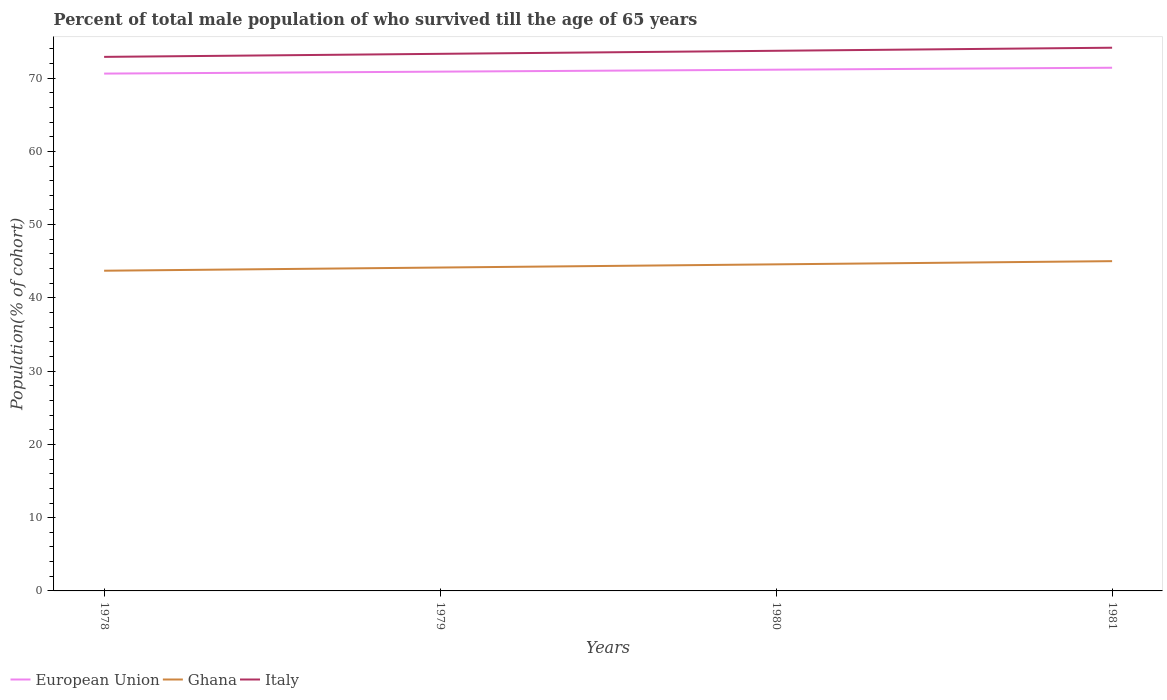How many different coloured lines are there?
Offer a terse response. 3. Is the number of lines equal to the number of legend labels?
Provide a short and direct response. Yes. Across all years, what is the maximum percentage of total male population who survived till the age of 65 years in Italy?
Offer a very short reply. 72.9. In which year was the percentage of total male population who survived till the age of 65 years in Italy maximum?
Offer a terse response. 1978. What is the total percentage of total male population who survived till the age of 65 years in Ghana in the graph?
Give a very brief answer. -1.3. What is the difference between the highest and the second highest percentage of total male population who survived till the age of 65 years in Italy?
Keep it short and to the point. 1.25. Is the percentage of total male population who survived till the age of 65 years in Ghana strictly greater than the percentage of total male population who survived till the age of 65 years in Italy over the years?
Provide a succinct answer. Yes. How many lines are there?
Provide a succinct answer. 3. Does the graph contain any zero values?
Offer a terse response. No. What is the title of the graph?
Your response must be concise. Percent of total male population of who survived till the age of 65 years. Does "High income: OECD" appear as one of the legend labels in the graph?
Offer a terse response. No. What is the label or title of the X-axis?
Make the answer very short. Years. What is the label or title of the Y-axis?
Give a very brief answer. Population(% of cohort). What is the Population(% of cohort) in European Union in 1978?
Your response must be concise. 70.62. What is the Population(% of cohort) of Ghana in 1978?
Keep it short and to the point. 43.71. What is the Population(% of cohort) in Italy in 1978?
Your answer should be very brief. 72.9. What is the Population(% of cohort) of European Union in 1979?
Give a very brief answer. 70.89. What is the Population(% of cohort) in Ghana in 1979?
Ensure brevity in your answer.  44.15. What is the Population(% of cohort) in Italy in 1979?
Your answer should be very brief. 73.32. What is the Population(% of cohort) of European Union in 1980?
Your answer should be very brief. 71.15. What is the Population(% of cohort) of Ghana in 1980?
Make the answer very short. 44.58. What is the Population(% of cohort) of Italy in 1980?
Your answer should be compact. 73.74. What is the Population(% of cohort) in European Union in 1981?
Ensure brevity in your answer.  71.42. What is the Population(% of cohort) in Ghana in 1981?
Provide a succinct answer. 45.02. What is the Population(% of cohort) of Italy in 1981?
Offer a terse response. 74.15. Across all years, what is the maximum Population(% of cohort) in European Union?
Offer a terse response. 71.42. Across all years, what is the maximum Population(% of cohort) of Ghana?
Ensure brevity in your answer.  45.02. Across all years, what is the maximum Population(% of cohort) of Italy?
Your answer should be compact. 74.15. Across all years, what is the minimum Population(% of cohort) in European Union?
Give a very brief answer. 70.62. Across all years, what is the minimum Population(% of cohort) of Ghana?
Provide a succinct answer. 43.71. Across all years, what is the minimum Population(% of cohort) in Italy?
Your answer should be very brief. 72.9. What is the total Population(% of cohort) of European Union in the graph?
Make the answer very short. 284.09. What is the total Population(% of cohort) in Ghana in the graph?
Your answer should be very brief. 177.45. What is the total Population(% of cohort) in Italy in the graph?
Provide a short and direct response. 294.11. What is the difference between the Population(% of cohort) in European Union in 1978 and that in 1979?
Provide a succinct answer. -0.27. What is the difference between the Population(% of cohort) of Ghana in 1978 and that in 1979?
Your response must be concise. -0.43. What is the difference between the Population(% of cohort) in Italy in 1978 and that in 1979?
Provide a short and direct response. -0.42. What is the difference between the Population(% of cohort) in European Union in 1978 and that in 1980?
Give a very brief answer. -0.53. What is the difference between the Population(% of cohort) of Ghana in 1978 and that in 1980?
Give a very brief answer. -0.87. What is the difference between the Population(% of cohort) in Italy in 1978 and that in 1980?
Keep it short and to the point. -0.83. What is the difference between the Population(% of cohort) of European Union in 1978 and that in 1981?
Provide a short and direct response. -0.8. What is the difference between the Population(% of cohort) of Ghana in 1978 and that in 1981?
Offer a very short reply. -1.3. What is the difference between the Population(% of cohort) of Italy in 1978 and that in 1981?
Your response must be concise. -1.25. What is the difference between the Population(% of cohort) in European Union in 1979 and that in 1980?
Your answer should be very brief. -0.27. What is the difference between the Population(% of cohort) in Ghana in 1979 and that in 1980?
Offer a very short reply. -0.43. What is the difference between the Population(% of cohort) of Italy in 1979 and that in 1980?
Keep it short and to the point. -0.42. What is the difference between the Population(% of cohort) of European Union in 1979 and that in 1981?
Give a very brief answer. -0.53. What is the difference between the Population(% of cohort) in Ghana in 1979 and that in 1981?
Provide a succinct answer. -0.87. What is the difference between the Population(% of cohort) of Italy in 1979 and that in 1981?
Ensure brevity in your answer.  -0.83. What is the difference between the Population(% of cohort) of European Union in 1980 and that in 1981?
Give a very brief answer. -0.27. What is the difference between the Population(% of cohort) in Ghana in 1980 and that in 1981?
Provide a succinct answer. -0.43. What is the difference between the Population(% of cohort) of Italy in 1980 and that in 1981?
Your response must be concise. -0.42. What is the difference between the Population(% of cohort) of European Union in 1978 and the Population(% of cohort) of Ghana in 1979?
Offer a very short reply. 26.48. What is the difference between the Population(% of cohort) in European Union in 1978 and the Population(% of cohort) in Italy in 1979?
Provide a succinct answer. -2.7. What is the difference between the Population(% of cohort) of Ghana in 1978 and the Population(% of cohort) of Italy in 1979?
Your answer should be compact. -29.61. What is the difference between the Population(% of cohort) in European Union in 1978 and the Population(% of cohort) in Ghana in 1980?
Your response must be concise. 26.04. What is the difference between the Population(% of cohort) of European Union in 1978 and the Population(% of cohort) of Italy in 1980?
Your answer should be compact. -3.11. What is the difference between the Population(% of cohort) in Ghana in 1978 and the Population(% of cohort) in Italy in 1980?
Offer a very short reply. -30.02. What is the difference between the Population(% of cohort) in European Union in 1978 and the Population(% of cohort) in Ghana in 1981?
Your answer should be compact. 25.61. What is the difference between the Population(% of cohort) of European Union in 1978 and the Population(% of cohort) of Italy in 1981?
Your answer should be compact. -3.53. What is the difference between the Population(% of cohort) in Ghana in 1978 and the Population(% of cohort) in Italy in 1981?
Ensure brevity in your answer.  -30.44. What is the difference between the Population(% of cohort) of European Union in 1979 and the Population(% of cohort) of Ghana in 1980?
Your answer should be very brief. 26.31. What is the difference between the Population(% of cohort) of European Union in 1979 and the Population(% of cohort) of Italy in 1980?
Offer a terse response. -2.85. What is the difference between the Population(% of cohort) in Ghana in 1979 and the Population(% of cohort) in Italy in 1980?
Offer a very short reply. -29.59. What is the difference between the Population(% of cohort) of European Union in 1979 and the Population(% of cohort) of Ghana in 1981?
Keep it short and to the point. 25.87. What is the difference between the Population(% of cohort) in European Union in 1979 and the Population(% of cohort) in Italy in 1981?
Keep it short and to the point. -3.26. What is the difference between the Population(% of cohort) of Ghana in 1979 and the Population(% of cohort) of Italy in 1981?
Your answer should be very brief. -30.01. What is the difference between the Population(% of cohort) of European Union in 1980 and the Population(% of cohort) of Ghana in 1981?
Offer a very short reply. 26.14. What is the difference between the Population(% of cohort) in European Union in 1980 and the Population(% of cohort) in Italy in 1981?
Your answer should be very brief. -3. What is the difference between the Population(% of cohort) in Ghana in 1980 and the Population(% of cohort) in Italy in 1981?
Make the answer very short. -29.57. What is the average Population(% of cohort) of European Union per year?
Ensure brevity in your answer.  71.02. What is the average Population(% of cohort) of Ghana per year?
Your response must be concise. 44.36. What is the average Population(% of cohort) in Italy per year?
Keep it short and to the point. 73.53. In the year 1978, what is the difference between the Population(% of cohort) of European Union and Population(% of cohort) of Ghana?
Provide a short and direct response. 26.91. In the year 1978, what is the difference between the Population(% of cohort) of European Union and Population(% of cohort) of Italy?
Provide a succinct answer. -2.28. In the year 1978, what is the difference between the Population(% of cohort) in Ghana and Population(% of cohort) in Italy?
Your answer should be very brief. -29.19. In the year 1979, what is the difference between the Population(% of cohort) in European Union and Population(% of cohort) in Ghana?
Keep it short and to the point. 26.74. In the year 1979, what is the difference between the Population(% of cohort) of European Union and Population(% of cohort) of Italy?
Ensure brevity in your answer.  -2.43. In the year 1979, what is the difference between the Population(% of cohort) in Ghana and Population(% of cohort) in Italy?
Keep it short and to the point. -29.17. In the year 1980, what is the difference between the Population(% of cohort) in European Union and Population(% of cohort) in Ghana?
Keep it short and to the point. 26.57. In the year 1980, what is the difference between the Population(% of cohort) in European Union and Population(% of cohort) in Italy?
Your response must be concise. -2.58. In the year 1980, what is the difference between the Population(% of cohort) in Ghana and Population(% of cohort) in Italy?
Give a very brief answer. -29.15. In the year 1981, what is the difference between the Population(% of cohort) in European Union and Population(% of cohort) in Ghana?
Offer a very short reply. 26.41. In the year 1981, what is the difference between the Population(% of cohort) in European Union and Population(% of cohort) in Italy?
Your answer should be compact. -2.73. In the year 1981, what is the difference between the Population(% of cohort) in Ghana and Population(% of cohort) in Italy?
Offer a terse response. -29.14. What is the ratio of the Population(% of cohort) of European Union in 1978 to that in 1979?
Make the answer very short. 1. What is the ratio of the Population(% of cohort) in Ghana in 1978 to that in 1979?
Offer a terse response. 0.99. What is the ratio of the Population(% of cohort) in Ghana in 1978 to that in 1980?
Make the answer very short. 0.98. What is the ratio of the Population(% of cohort) in Italy in 1978 to that in 1980?
Ensure brevity in your answer.  0.99. What is the ratio of the Population(% of cohort) of Italy in 1978 to that in 1981?
Provide a short and direct response. 0.98. What is the ratio of the Population(% of cohort) of Ghana in 1979 to that in 1980?
Offer a terse response. 0.99. What is the ratio of the Population(% of cohort) in Italy in 1979 to that in 1980?
Ensure brevity in your answer.  0.99. What is the ratio of the Population(% of cohort) of Ghana in 1979 to that in 1981?
Keep it short and to the point. 0.98. What is the ratio of the Population(% of cohort) in Ghana in 1980 to that in 1981?
Ensure brevity in your answer.  0.99. What is the difference between the highest and the second highest Population(% of cohort) in European Union?
Provide a succinct answer. 0.27. What is the difference between the highest and the second highest Population(% of cohort) of Ghana?
Offer a very short reply. 0.43. What is the difference between the highest and the second highest Population(% of cohort) of Italy?
Offer a terse response. 0.42. What is the difference between the highest and the lowest Population(% of cohort) in European Union?
Provide a succinct answer. 0.8. What is the difference between the highest and the lowest Population(% of cohort) in Ghana?
Provide a short and direct response. 1.3. What is the difference between the highest and the lowest Population(% of cohort) in Italy?
Your answer should be very brief. 1.25. 